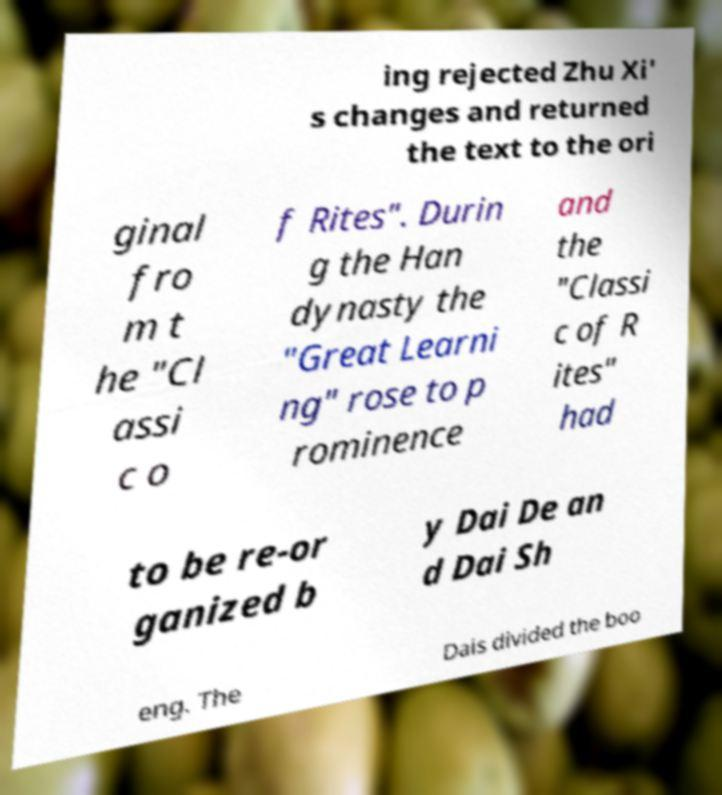For documentation purposes, I need the text within this image transcribed. Could you provide that? ing rejected Zhu Xi' s changes and returned the text to the ori ginal fro m t he "Cl assi c o f Rites". Durin g the Han dynasty the "Great Learni ng" rose to p rominence and the "Classi c of R ites" had to be re-or ganized b y Dai De an d Dai Sh eng. The Dais divided the boo 